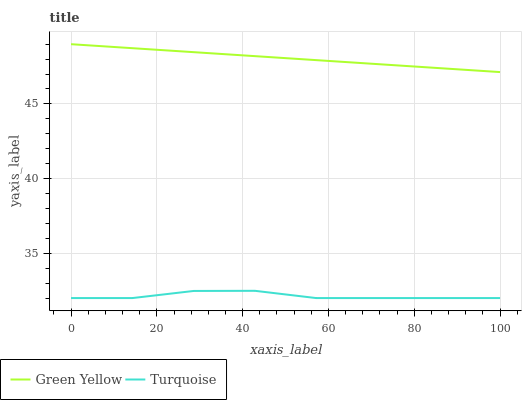Does Turquoise have the minimum area under the curve?
Answer yes or no. Yes. Does Green Yellow have the maximum area under the curve?
Answer yes or no. Yes. Does Green Yellow have the minimum area under the curve?
Answer yes or no. No. Is Green Yellow the smoothest?
Answer yes or no. Yes. Is Turquoise the roughest?
Answer yes or no. Yes. Is Green Yellow the roughest?
Answer yes or no. No. Does Turquoise have the lowest value?
Answer yes or no. Yes. Does Green Yellow have the lowest value?
Answer yes or no. No. Does Green Yellow have the highest value?
Answer yes or no. Yes. Is Turquoise less than Green Yellow?
Answer yes or no. Yes. Is Green Yellow greater than Turquoise?
Answer yes or no. Yes. Does Turquoise intersect Green Yellow?
Answer yes or no. No. 